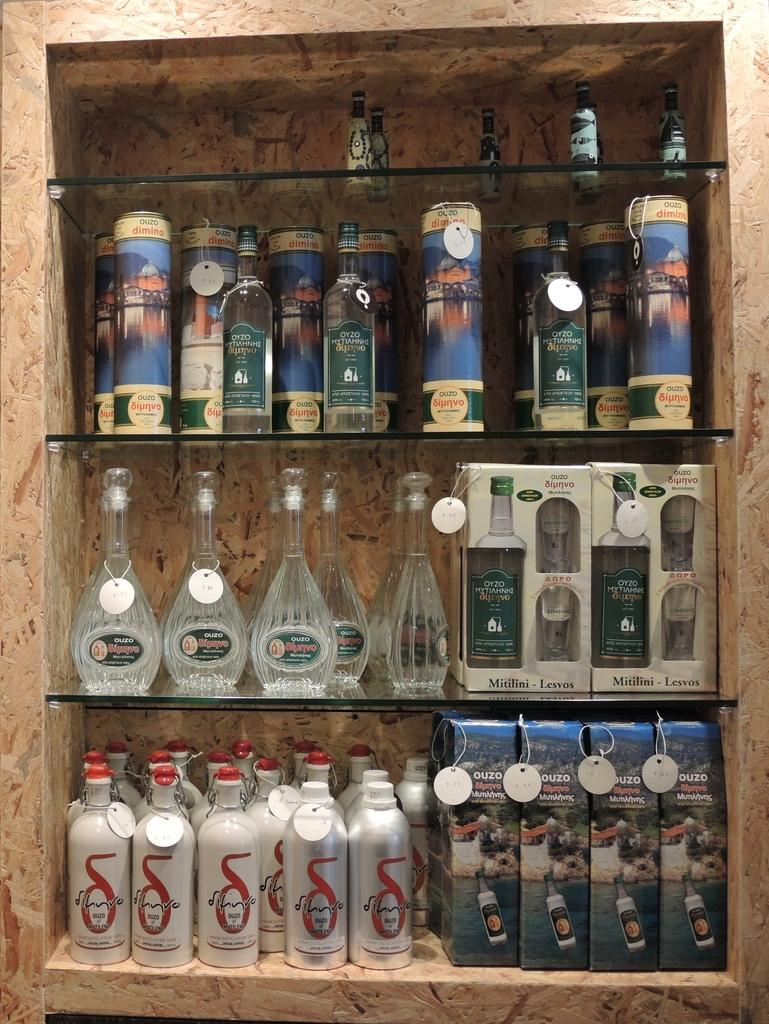What type of beverage bottles are in the image? There are wine bottles in the image. Can you describe the variety of wine bottles? The wine bottles are of different brands. Where are the wine bottles placed in the image? The wine bottles are on a glass shelf. Can you tell me how many times the aunt jumps in the image? There is no aunt or jumping activity present in the image. What is the color of the sky in the image? The provided facts do not mention the sky or its color, so it cannot be determined from the image. 